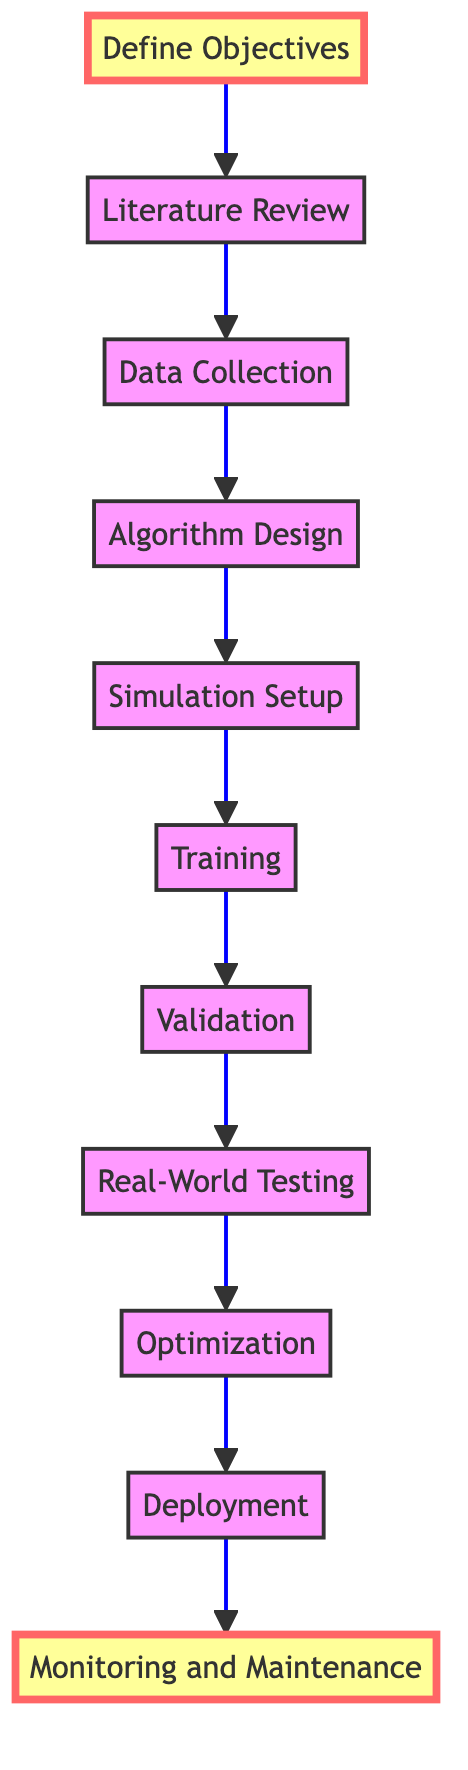What is the first step in the diagram? The first step is "Define Objectives," which is at the bottom of the flow chart.
Answer: Define Objectives How many steps are there in total? Counting all the nodes from "Define Objectives" to "Monitoring and Maintenance," there are 11 steps shown in the diagram.
Answer: 11 What is the final step in the process? The final step is "Monitoring and Maintenance," which is at the top of the flow chart.
Answer: Monitoring and Maintenance Which two steps come directly before "Real-World Testing"? The two steps before "Real-World Testing" are "Validation" and "Training," as indicated by the arrows that lead into "Real-World Testing."
Answer: Validation, Training What is the relationship between "Algorithm Design" and "Data Collection"? "Algorithm Design" directly follows "Data Collection" in the diagram, indicating that data collected is used to design the algorithm.
Answer: Data Collection → Algorithm Design How many steps involve testing or validation? There are three steps that involve testing or validation: "Validation," "Real-World Testing," and "Monitoring and Maintenance."
Answer: 3 Which step is emphasized in a distinct style? Both "Define Objectives" and "Monitoring and Maintenance" are emphasized with a different style in the diagram, indicating their importance in the process.
Answer: Define Objectives, Monitoring and Maintenance What is the purpose of the "Optimization" step? The purpose of the "Optimization" step is to analyze performance data and refine the algorithm for better efficiency and reliability.
Answer: Analyze performance data What precedes the "Deployment" step? The step that precedes "Deployment" is "Optimization," which indicates that optimization needs to be completed before deploying the algorithm into the robotic system.
Answer: Optimization What key activities are included in the "Training" step? The "Training" step includes training the algorithm using collected data and refining it through iterations, ensuring good generalization.
Answer: Train the algorithm with data 